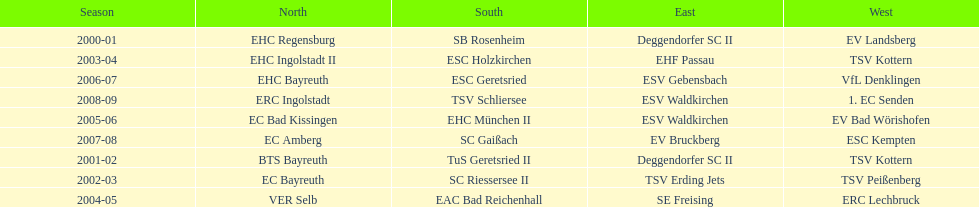Beginning with the 2007-08 season, is ecs kempten present in any of the earlier years? No. 